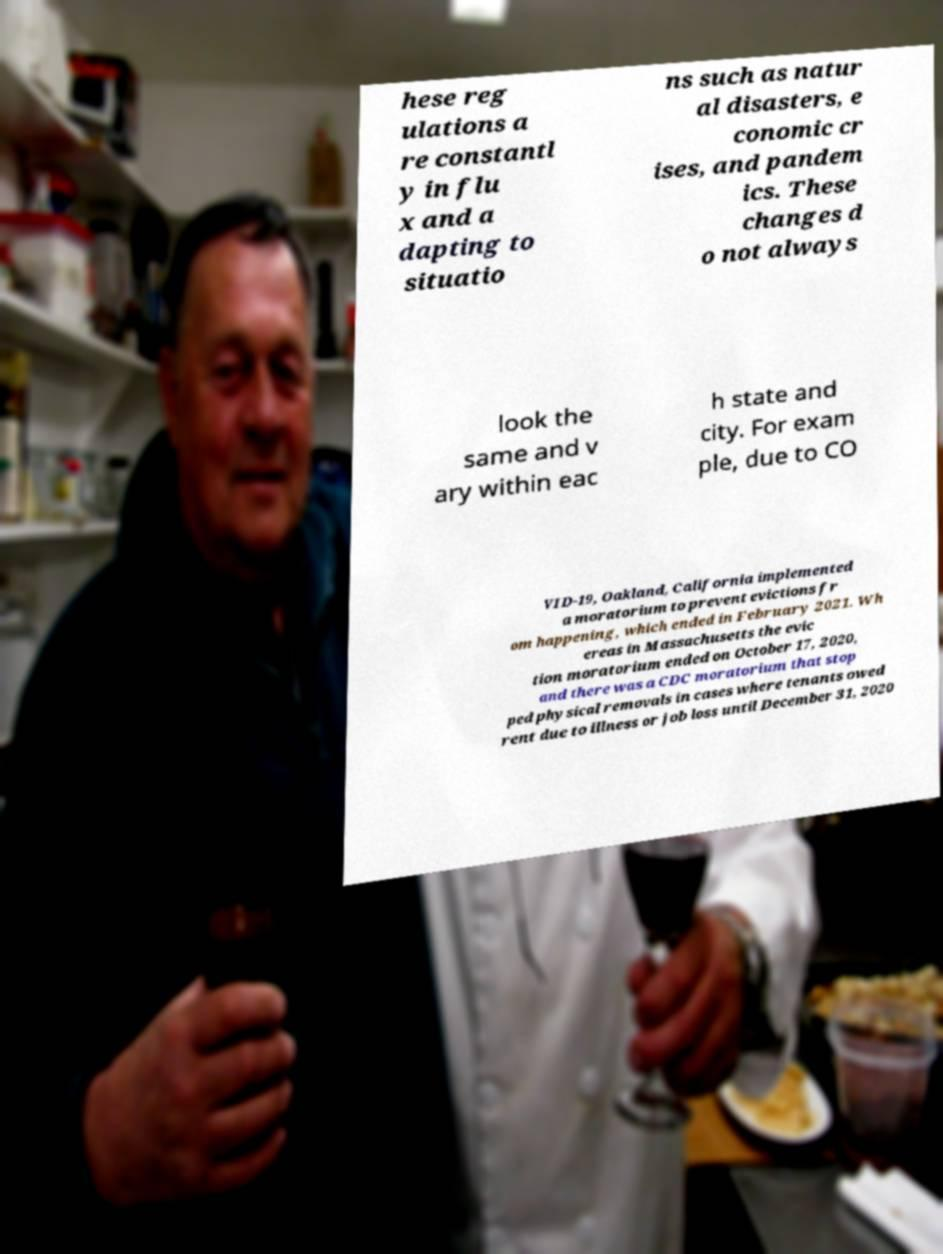For documentation purposes, I need the text within this image transcribed. Could you provide that? hese reg ulations a re constantl y in flu x and a dapting to situatio ns such as natur al disasters, e conomic cr ises, and pandem ics. These changes d o not always look the same and v ary within eac h state and city. For exam ple, due to CO VID-19, Oakland, California implemented a moratorium to prevent evictions fr om happening, which ended in February 2021. Wh ereas in Massachusetts the evic tion moratorium ended on October 17, 2020, and there was a CDC moratorium that stop ped physical removals in cases where tenants owed rent due to illness or job loss until December 31, 2020 